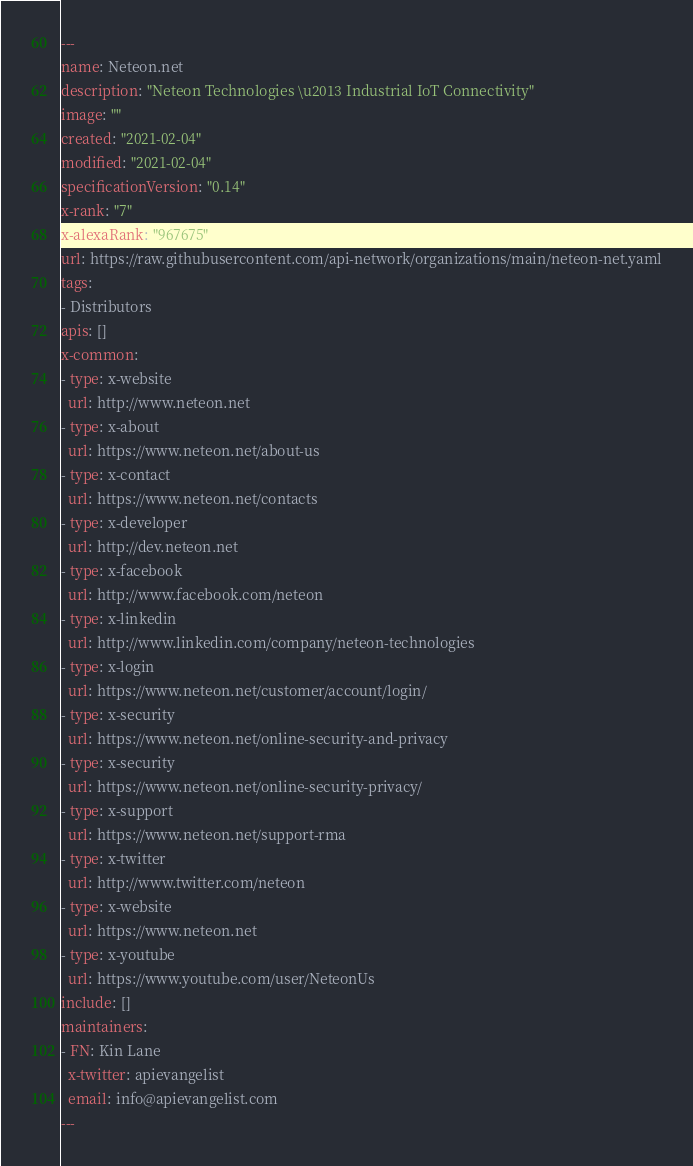Convert code to text. <code><loc_0><loc_0><loc_500><loc_500><_YAML_>---
name: Neteon.net
description: "Neteon Technologies \u2013 Industrial IoT Connectivity"
image: ""
created: "2021-02-04"
modified: "2021-02-04"
specificationVersion: "0.14"
x-rank: "7"
x-alexaRank: "967675"
url: https://raw.githubusercontent.com/api-network/organizations/main/neteon-net.yaml
tags:
- Distributors
apis: []
x-common:
- type: x-website
  url: http://www.neteon.net
- type: x-about
  url: https://www.neteon.net/about-us
- type: x-contact
  url: https://www.neteon.net/contacts
- type: x-developer
  url: http://dev.neteon.net
- type: x-facebook
  url: http://www.facebook.com/neteon
- type: x-linkedin
  url: http://www.linkedin.com/company/neteon-technologies
- type: x-login
  url: https://www.neteon.net/customer/account/login/
- type: x-security
  url: https://www.neteon.net/online-security-and-privacy
- type: x-security
  url: https://www.neteon.net/online-security-privacy/
- type: x-support
  url: https://www.neteon.net/support-rma
- type: x-twitter
  url: http://www.twitter.com/neteon
- type: x-website
  url: https://www.neteon.net
- type: x-youtube
  url: https://www.youtube.com/user/NeteonUs
include: []
maintainers:
- FN: Kin Lane
  x-twitter: apievangelist
  email: info@apievangelist.com
---</code> 